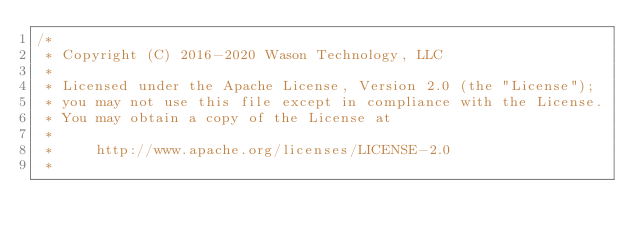<code> <loc_0><loc_0><loc_500><loc_500><_C++_>/*
 * Copyright (C) 2016-2020 Wason Technology, LLC
 *
 * Licensed under the Apache License, Version 2.0 (the "License");
 * you may not use this file except in compliance with the License.
 * You may obtain a copy of the License at
 *
 *     http://www.apache.org/licenses/LICENSE-2.0
 *</code> 